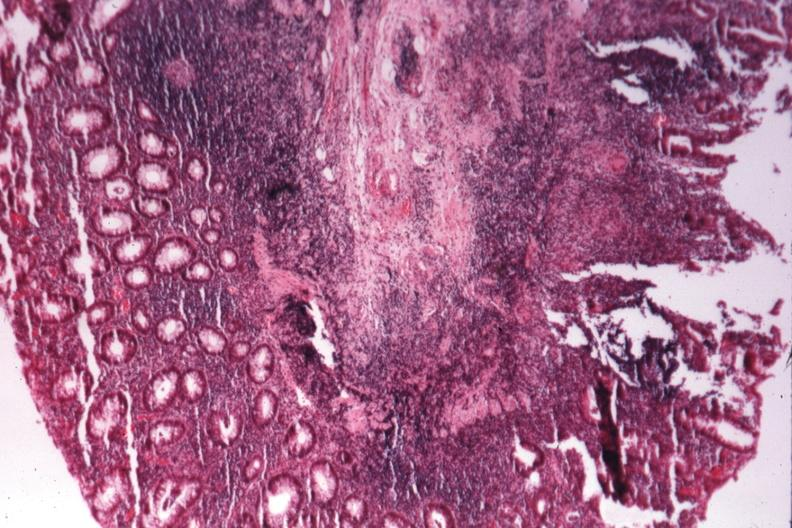what is present?
Answer the question using a single word or phrase. Gastrointestinal 